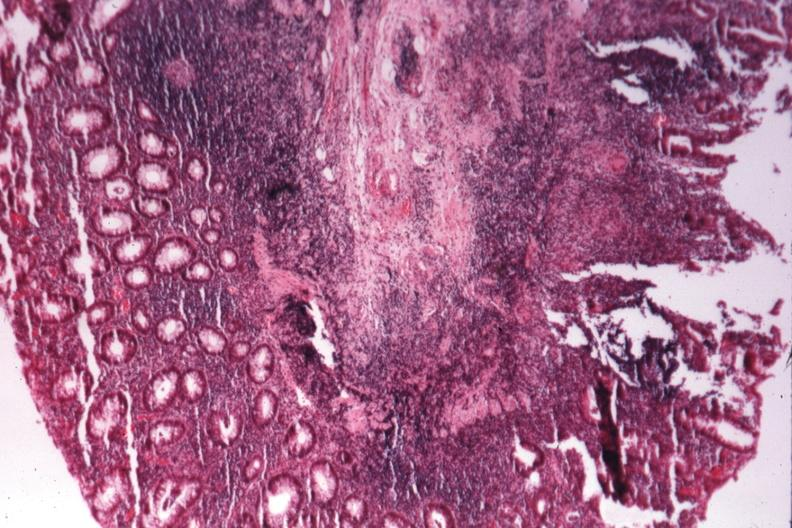what is present?
Answer the question using a single word or phrase. Gastrointestinal 